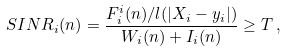<formula> <loc_0><loc_0><loc_500><loc_500>S I N R _ { i } ( n ) = \frac { F _ { i } ^ { i } ( n ) / l ( | X _ { i } - y _ { i } | ) } { W _ { i } ( n ) + I _ { i } ( n ) } \geq T \, ,</formula> 